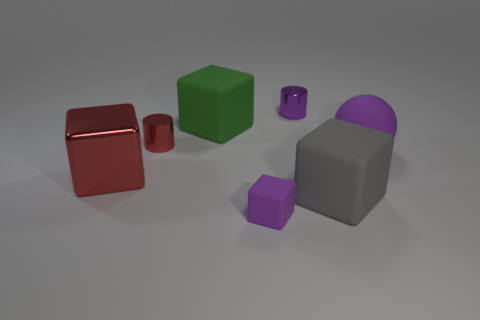Subtract all tiny purple rubber blocks. How many blocks are left? 3 Add 2 rubber blocks. How many objects exist? 9 Subtract all gray blocks. How many blocks are left? 3 Subtract 2 cubes. How many cubes are left? 2 Add 5 big green rubber blocks. How many big green rubber blocks are left? 6 Add 1 small red metal cylinders. How many small red metal cylinders exist? 2 Subtract 0 yellow cylinders. How many objects are left? 7 Subtract all cubes. How many objects are left? 3 Subtract all brown cubes. Subtract all yellow spheres. How many cubes are left? 4 Subtract all small red objects. Subtract all big green matte cubes. How many objects are left? 5 